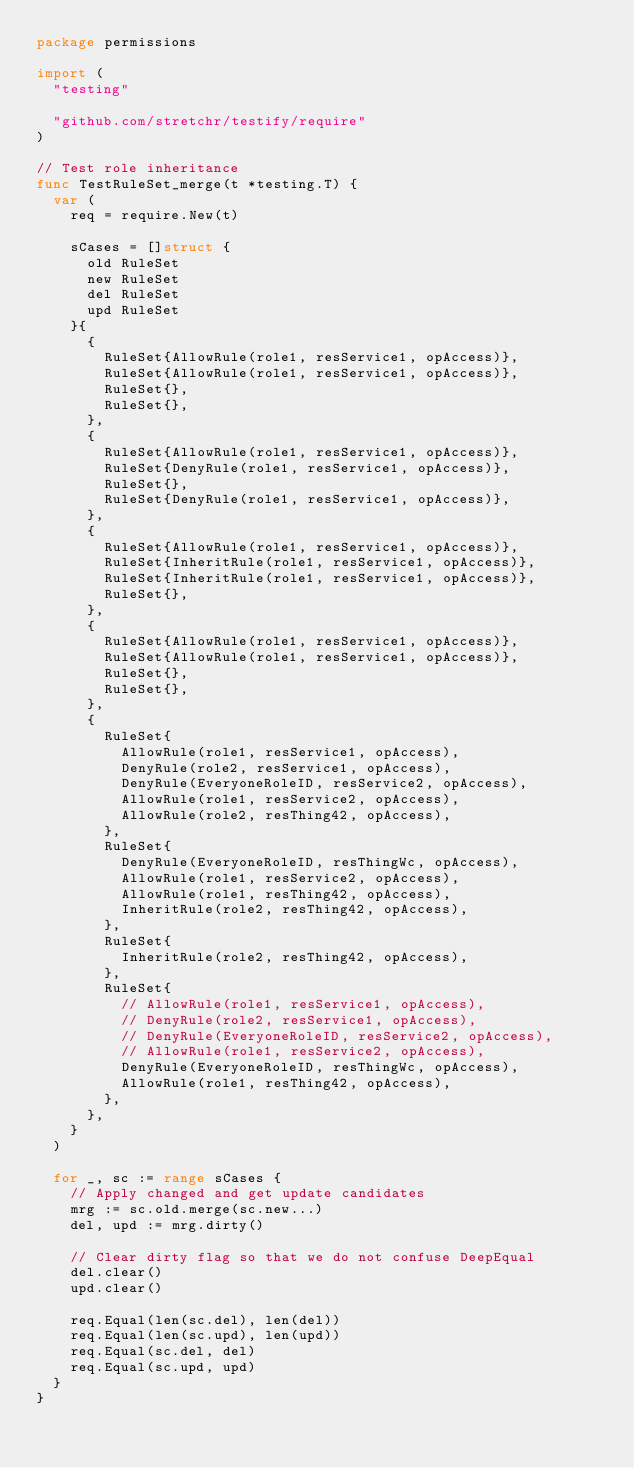<code> <loc_0><loc_0><loc_500><loc_500><_Go_>package permissions

import (
	"testing"

	"github.com/stretchr/testify/require"
)

// Test role inheritance
func TestRuleSet_merge(t *testing.T) {
	var (
		req = require.New(t)

		sCases = []struct {
			old RuleSet
			new RuleSet
			del RuleSet
			upd RuleSet
		}{
			{
				RuleSet{AllowRule(role1, resService1, opAccess)},
				RuleSet{AllowRule(role1, resService1, opAccess)},
				RuleSet{},
				RuleSet{},
			},
			{
				RuleSet{AllowRule(role1, resService1, opAccess)},
				RuleSet{DenyRule(role1, resService1, opAccess)},
				RuleSet{},
				RuleSet{DenyRule(role1, resService1, opAccess)},
			},
			{
				RuleSet{AllowRule(role1, resService1, opAccess)},
				RuleSet{InheritRule(role1, resService1, opAccess)},
				RuleSet{InheritRule(role1, resService1, opAccess)},
				RuleSet{},
			},
			{
				RuleSet{AllowRule(role1, resService1, opAccess)},
				RuleSet{AllowRule(role1, resService1, opAccess)},
				RuleSet{},
				RuleSet{},
			},
			{
				RuleSet{
					AllowRule(role1, resService1, opAccess),
					DenyRule(role2, resService1, opAccess),
					DenyRule(EveryoneRoleID, resService2, opAccess),
					AllowRule(role1, resService2, opAccess),
					AllowRule(role2, resThing42, opAccess),
				},
				RuleSet{
					DenyRule(EveryoneRoleID, resThingWc, opAccess),
					AllowRule(role1, resService2, opAccess),
					AllowRule(role1, resThing42, opAccess),
					InheritRule(role2, resThing42, opAccess),
				},
				RuleSet{
					InheritRule(role2, resThing42, opAccess),
				},
				RuleSet{
					// AllowRule(role1, resService1, opAccess),
					// DenyRule(role2, resService1, opAccess),
					// DenyRule(EveryoneRoleID, resService2, opAccess),
					// AllowRule(role1, resService2, opAccess),
					DenyRule(EveryoneRoleID, resThingWc, opAccess),
					AllowRule(role1, resThing42, opAccess),
				},
			},
		}
	)

	for _, sc := range sCases {
		// Apply changed and get update candidates
		mrg := sc.old.merge(sc.new...)
		del, upd := mrg.dirty()

		// Clear dirty flag so that we do not confuse DeepEqual
		del.clear()
		upd.clear()

		req.Equal(len(sc.del), len(del))
		req.Equal(len(sc.upd), len(upd))
		req.Equal(sc.del, del)
		req.Equal(sc.upd, upd)
	}
}
</code> 